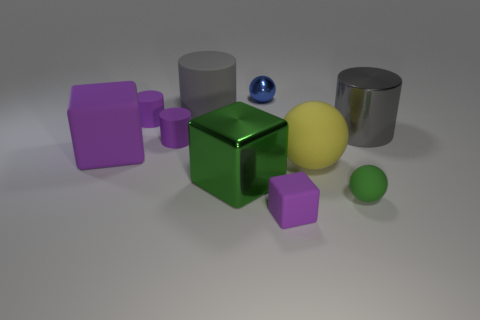Is there a purple rubber cylinder? yes 